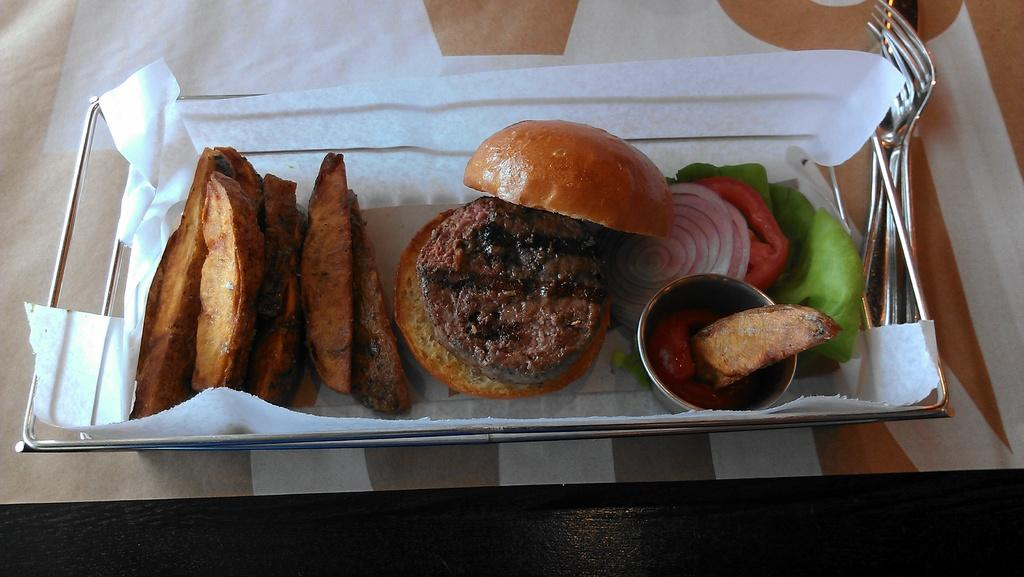What type of food can be seen in the image? There is a sandwich in the image. What is one of the main ingredients of the sandwich? There is bread in the image. How is the bread prepared in the sandwich? There is toast in the image. What condiment is visible in the image? There is ketchup in the image. What type of container is present in the image? There is a steel bowl in the image. What vegetable is present in the image? There is an onion in the image. What other vegetable is present in the image? There is a carrot in the image. What type of plant material is present in the image? There are leaves in the image. What type of disposable material is present in the image? There is tissue paper in the image. What utensils are on the table in the image? There are forks on the table in the image. What surface is present on the table in the image? There is a tray on the table in the image. Where is the vase located in the image? There is no vase present in the image. What is the thumb doing in the image? There is no thumb present in the image. How many eggs are visible in the image? There are no eggs present in the image. 